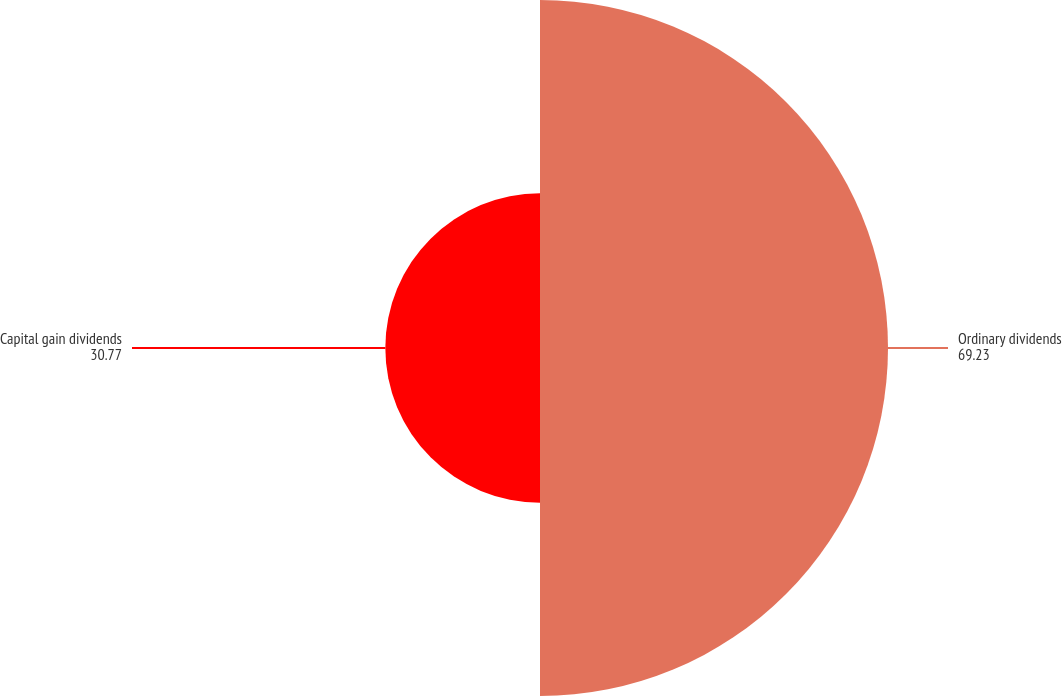<chart> <loc_0><loc_0><loc_500><loc_500><pie_chart><fcel>Ordinary dividends<fcel>Capital gain dividends<nl><fcel>69.23%<fcel>30.77%<nl></chart> 